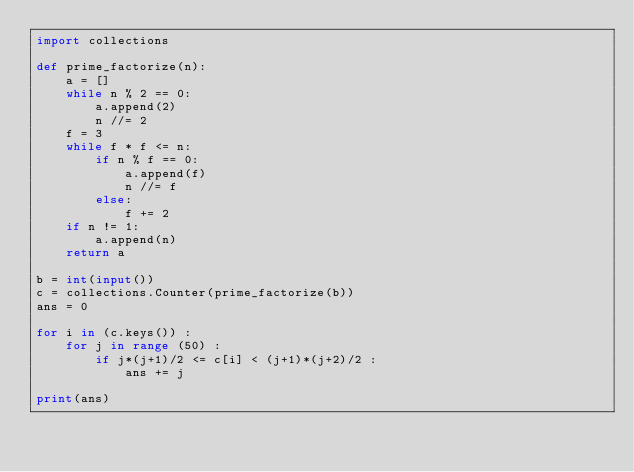<code> <loc_0><loc_0><loc_500><loc_500><_Python_>import collections

def prime_factorize(n):
    a = []
    while n % 2 == 0:
        a.append(2)
        n //= 2
    f = 3
    while f * f <= n:
        if n % f == 0:
            a.append(f)
            n //= f
        else:
            f += 2
    if n != 1:
        a.append(n)
    return a

b = int(input())
c = collections.Counter(prime_factorize(b))
ans = 0

for i in (c.keys()) :
    for j in range (50) :
        if j*(j+1)/2 <= c[i] < (j+1)*(j+2)/2 :
            ans += j

print(ans)</code> 